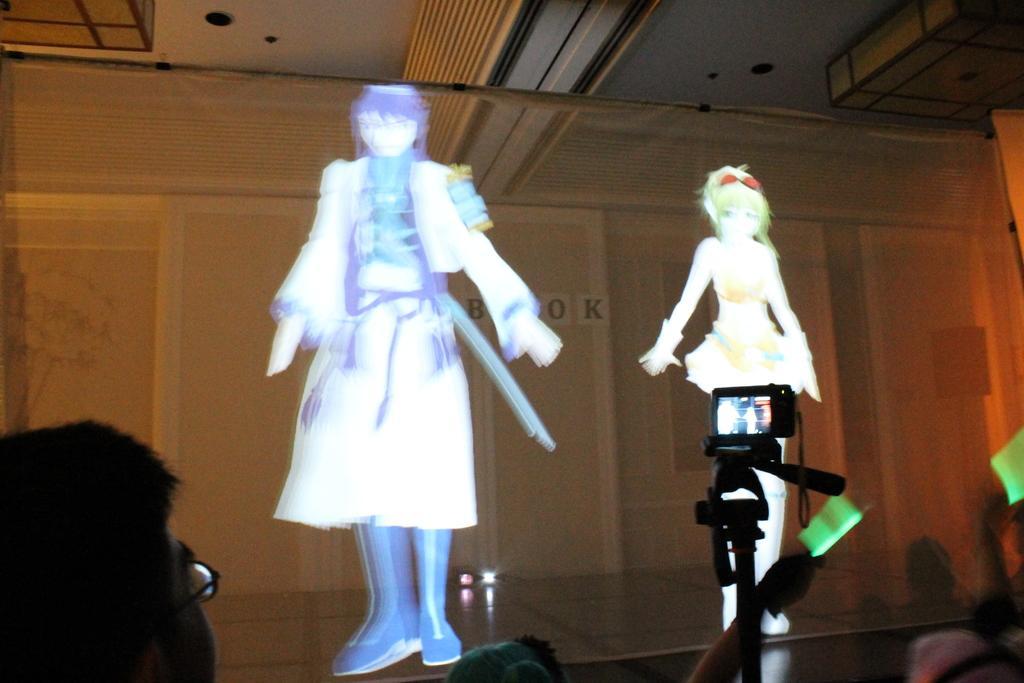Describe this image in one or two sentences. In this image there is a figurine of two personś, there is stage, there is light on the stage, there is a wall, there is a person wearing spectacles, there is a camera, there is a stand. 